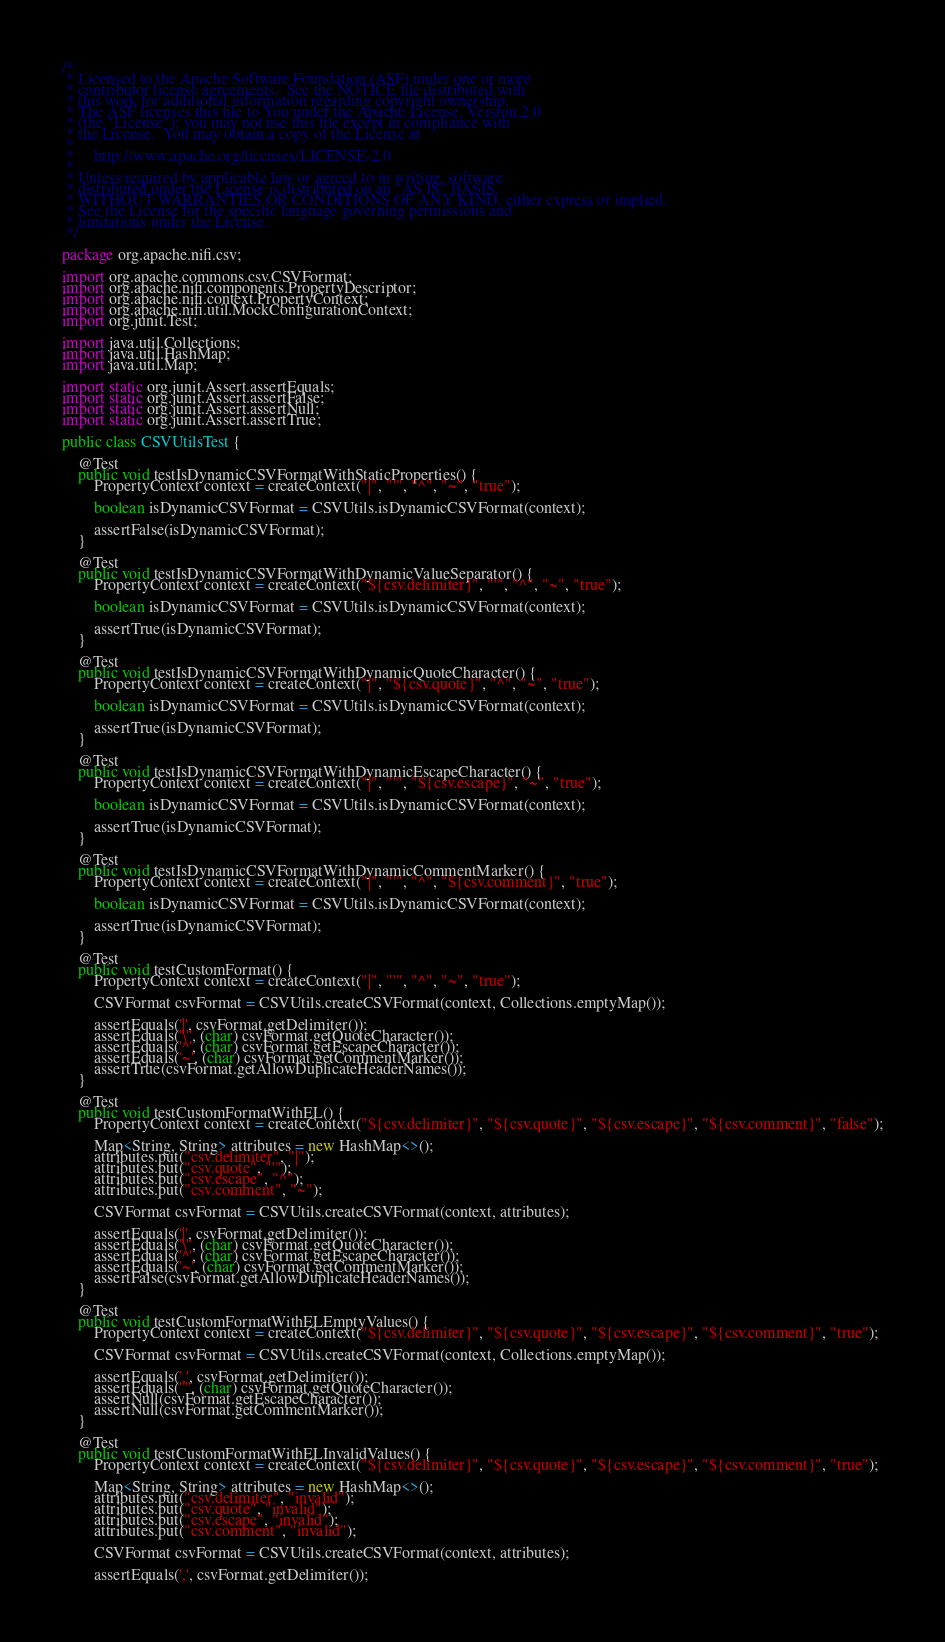<code> <loc_0><loc_0><loc_500><loc_500><_Java_>/*
 * Licensed to the Apache Software Foundation (ASF) under one or more
 * contributor license agreements.  See the NOTICE file distributed with
 * this work for additional information regarding copyright ownership.
 * The ASF licenses this file to You under the Apache License, Version 2.0
 * (the "License"); you may not use this file except in compliance with
 * the License.  You may obtain a copy of the License at
 *
 *     http://www.apache.org/licenses/LICENSE-2.0
 *
 * Unless required by applicable law or agreed to in writing, software
 * distributed under the License is distributed on an "AS IS" BASIS,
 * WITHOUT WARRANTIES OR CONDITIONS OF ANY KIND, either express or implied.
 * See the License for the specific language governing permissions and
 * limitations under the License.
 */

package org.apache.nifi.csv;

import org.apache.commons.csv.CSVFormat;
import org.apache.nifi.components.PropertyDescriptor;
import org.apache.nifi.context.PropertyContext;
import org.apache.nifi.util.MockConfigurationContext;
import org.junit.Test;

import java.util.Collections;
import java.util.HashMap;
import java.util.Map;

import static org.junit.Assert.assertEquals;
import static org.junit.Assert.assertFalse;
import static org.junit.Assert.assertNull;
import static org.junit.Assert.assertTrue;

public class CSVUtilsTest {

    @Test
    public void testIsDynamicCSVFormatWithStaticProperties() {
        PropertyContext context = createContext("|", "'", "^", "~", "true");

        boolean isDynamicCSVFormat = CSVUtils.isDynamicCSVFormat(context);

        assertFalse(isDynamicCSVFormat);
    }

    @Test
    public void testIsDynamicCSVFormatWithDynamicValueSeparator() {
        PropertyContext context = createContext("${csv.delimiter}", "'", "^", "~", "true");

        boolean isDynamicCSVFormat = CSVUtils.isDynamicCSVFormat(context);

        assertTrue(isDynamicCSVFormat);
    }

    @Test
    public void testIsDynamicCSVFormatWithDynamicQuoteCharacter() {
        PropertyContext context = createContext("|", "${csv.quote}", "^", "~", "true");

        boolean isDynamicCSVFormat = CSVUtils.isDynamicCSVFormat(context);

        assertTrue(isDynamicCSVFormat);
    }

    @Test
    public void testIsDynamicCSVFormatWithDynamicEscapeCharacter() {
        PropertyContext context = createContext("|", "'", "${csv.escape}", "~", "true");

        boolean isDynamicCSVFormat = CSVUtils.isDynamicCSVFormat(context);

        assertTrue(isDynamicCSVFormat);
    }

    @Test
    public void testIsDynamicCSVFormatWithDynamicCommentMarker() {
        PropertyContext context = createContext("|", "'", "^", "${csv.comment}", "true");

        boolean isDynamicCSVFormat = CSVUtils.isDynamicCSVFormat(context);

        assertTrue(isDynamicCSVFormat);
    }

    @Test
    public void testCustomFormat() {
        PropertyContext context = createContext("|", "'", "^", "~", "true");

        CSVFormat csvFormat = CSVUtils.createCSVFormat(context, Collections.emptyMap());

        assertEquals('|', csvFormat.getDelimiter());
        assertEquals('\'', (char) csvFormat.getQuoteCharacter());
        assertEquals('^', (char) csvFormat.getEscapeCharacter());
        assertEquals('~', (char) csvFormat.getCommentMarker());
        assertTrue(csvFormat.getAllowDuplicateHeaderNames());
    }

    @Test
    public void testCustomFormatWithEL() {
        PropertyContext context = createContext("${csv.delimiter}", "${csv.quote}", "${csv.escape}", "${csv.comment}", "false");

        Map<String, String> attributes = new HashMap<>();
        attributes.put("csv.delimiter", "|");
        attributes.put("csv.quote", "'");
        attributes.put("csv.escape", "^");
        attributes.put("csv.comment", "~");

        CSVFormat csvFormat = CSVUtils.createCSVFormat(context, attributes);

        assertEquals('|', csvFormat.getDelimiter());
        assertEquals('\'', (char) csvFormat.getQuoteCharacter());
        assertEquals('^', (char) csvFormat.getEscapeCharacter());
        assertEquals('~', (char) csvFormat.getCommentMarker());
        assertFalse(csvFormat.getAllowDuplicateHeaderNames());
    }

    @Test
    public void testCustomFormatWithELEmptyValues() {
        PropertyContext context = createContext("${csv.delimiter}", "${csv.quote}", "${csv.escape}", "${csv.comment}", "true");

        CSVFormat csvFormat = CSVUtils.createCSVFormat(context, Collections.emptyMap());

        assertEquals(',', csvFormat.getDelimiter());
        assertEquals('"', (char) csvFormat.getQuoteCharacter());
        assertNull(csvFormat.getEscapeCharacter());
        assertNull(csvFormat.getCommentMarker());
    }

    @Test
    public void testCustomFormatWithELInvalidValues() {
        PropertyContext context = createContext("${csv.delimiter}", "${csv.quote}", "${csv.escape}", "${csv.comment}", "true");

        Map<String, String> attributes = new HashMap<>();
        attributes.put("csv.delimiter", "invalid");
        attributes.put("csv.quote", "invalid");
        attributes.put("csv.escape", "invalid");
        attributes.put("csv.comment", "invalid");

        CSVFormat csvFormat = CSVUtils.createCSVFormat(context, attributes);

        assertEquals(',', csvFormat.getDelimiter());</code> 